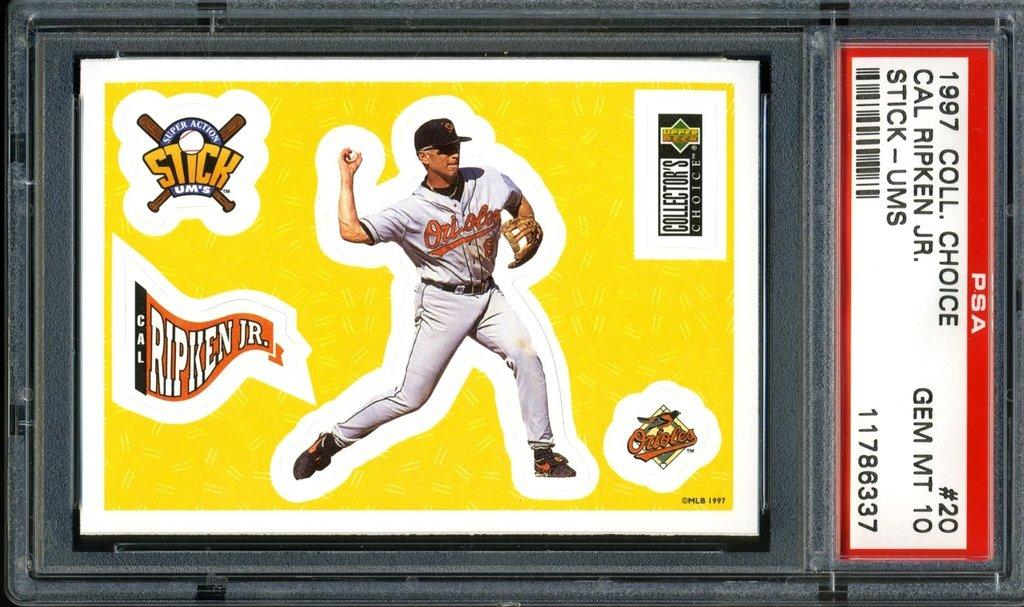Provide a one-sentence caption for the provided image. a framed picture that says 'cal ripken jr.' on it. 